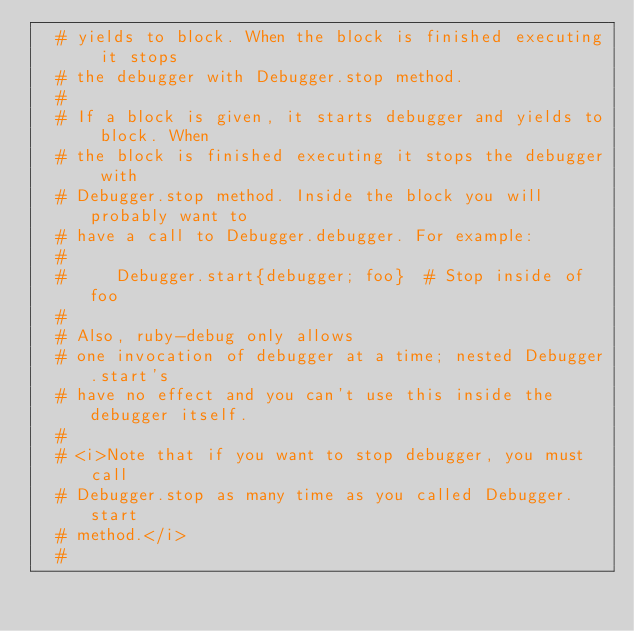<code> <loc_0><loc_0><loc_500><loc_500><_Ruby_>  # yields to block. When the block is finished executing it stops
  # the debugger with Debugger.stop method.
  #
  # If a block is given, it starts debugger and yields to block. When
  # the block is finished executing it stops the debugger with
  # Debugger.stop method. Inside the block you will probably want to
  # have a call to Debugger.debugger. For example:
  #
  #     Debugger.start{debugger; foo}  # Stop inside of foo
  #
  # Also, ruby-debug only allows
  # one invocation of debugger at a time; nested Debugger.start's
  # have no effect and you can't use this inside the debugger itself.
  #
  # <i>Note that if you want to stop debugger, you must call
  # Debugger.stop as many time as you called Debugger.start
  # method.</i>
  #</code> 